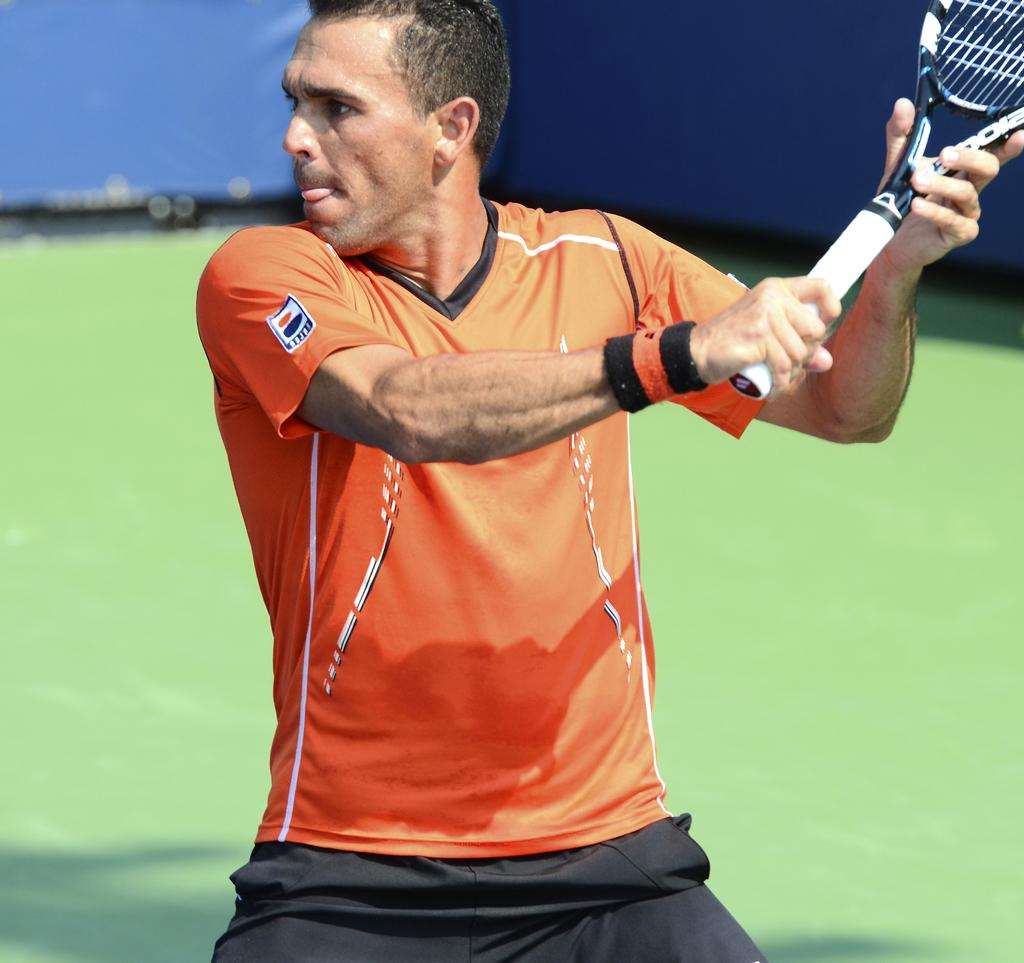What activity is the person in the image engaged in? The person is playing tennis in the image. What equipment is the person using to play tennis? The person is holding a tennis bat. How would you describe the weather in the image? The background of the image is sunny. What type of rock can be seen in the dirt in the image? There is no rock or dirt present in the image; it features a person playing tennis in a sunny background. 